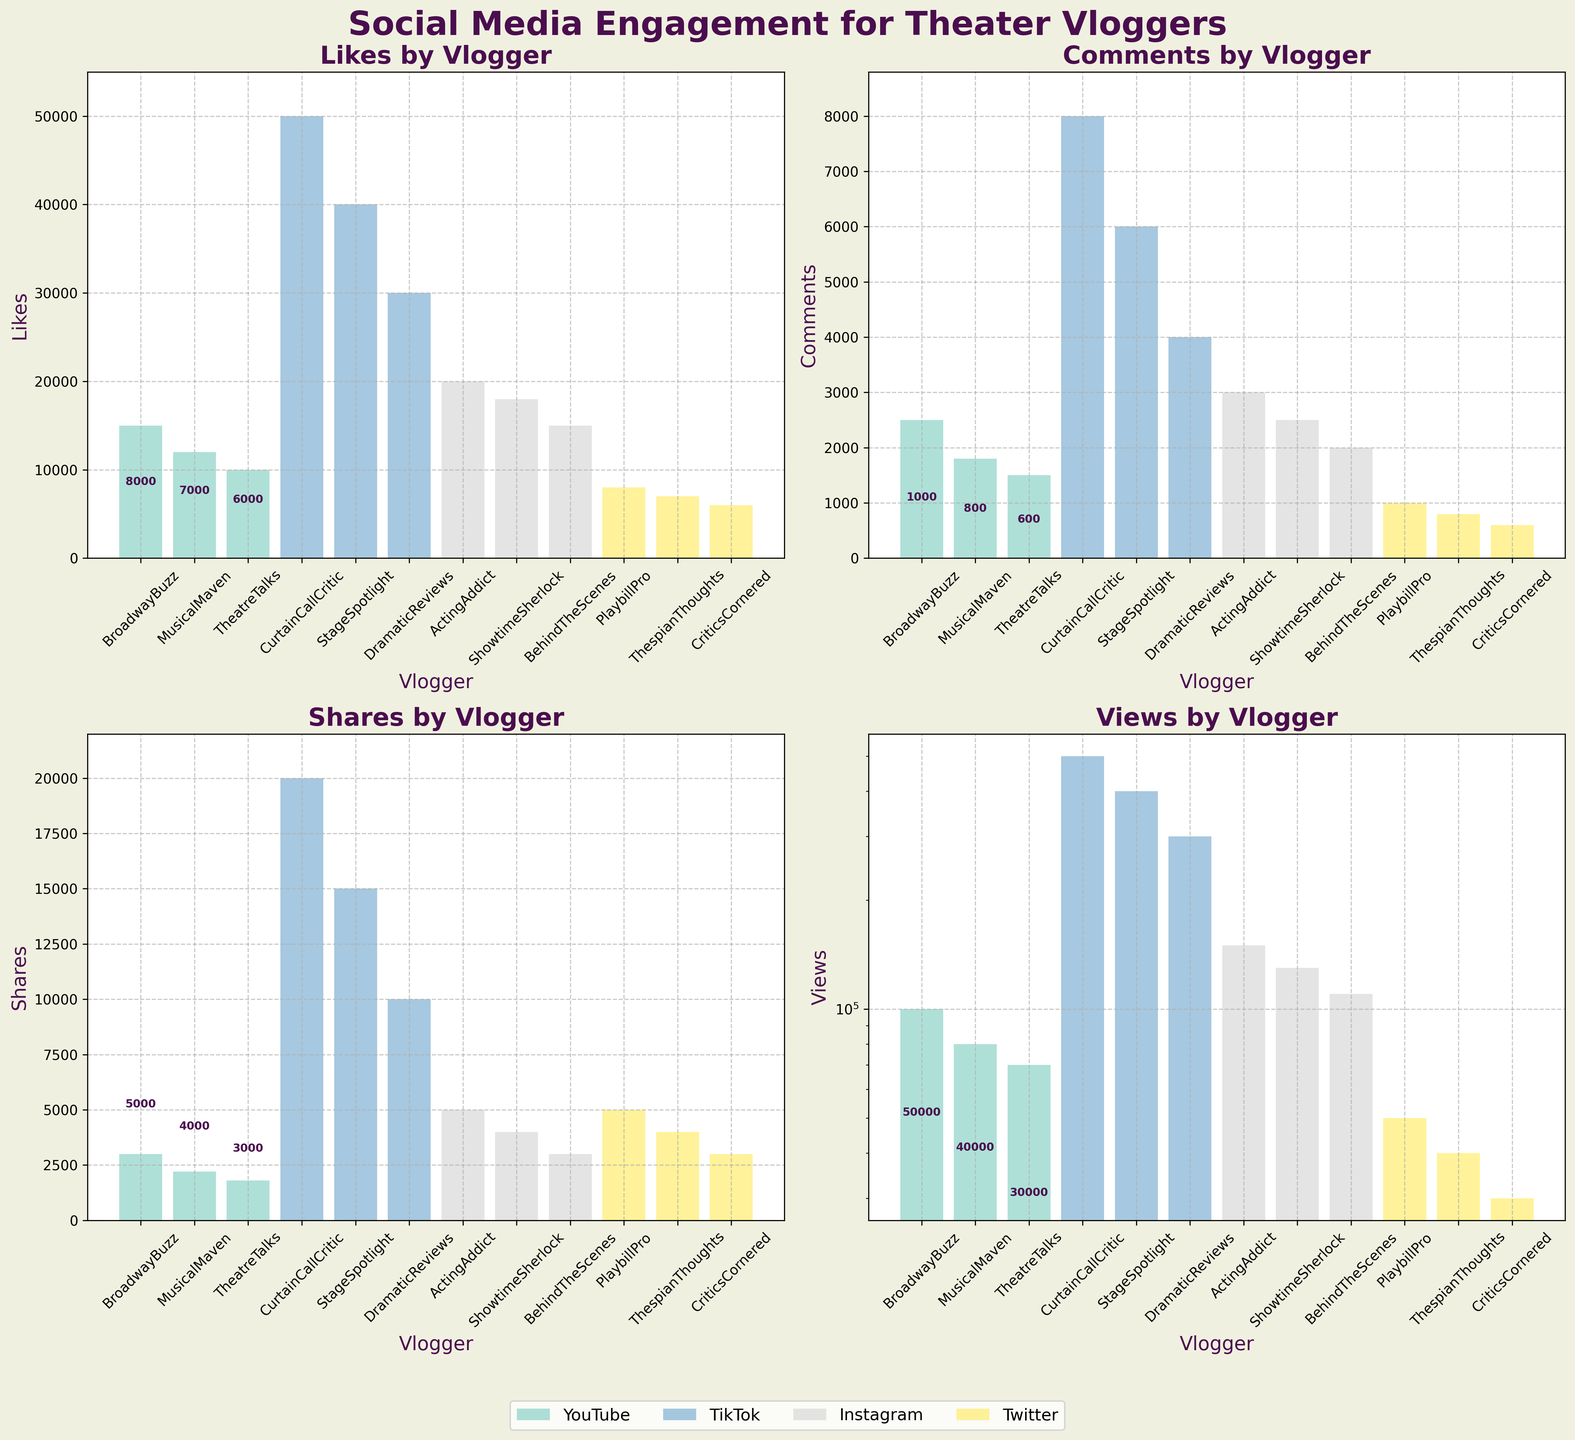What's the title of the figure? The title is at the top of the figure and reads "Social Media Engagement for Theater Vloggers".
Answer: Social Media Engagement for Theater Vloggers Which platform had the vlogger with the most Likes? The subplot for Likes shows that the highest bar is for CurtainCallCritic, which is associated with TikTok.
Answer: TikTok How many TikTok vloggers are included in the charts? From the legend and annotations on the bars in the subplots, there are three TikTok vloggers: CurtainCallCritic, StageSpotlight, and DramaticReviews.
Answer: 3 Which vlogger on YouTube received the most Shares? In the Shares subplot, look for the highest bar among YouTube vloggers—BroadwayBuzz has the highest bar with 3000 shares.
Answer: BroadwayBuzz What is the total number of Views across all platforms for the vlogger 'ActingAddict'? ActingAddict has bars in the Views subplot indicating 150,000 views.
Answer: 150,000 Which platform generally shows higher engagement in terms of Likes? By comparing the heights of the bars in the Likes subplot, TikTok generally has taller bars compared to other platforms, indicating higher engagement.
Answer: TikTok What differences can you observe between the number of Comments received by YouTube vloggers and Instagram vloggers? From the Comments subplot, YouTube vloggers have comments in the range of 1500-2500, while Instagram vloggers have comments ranging from 2000-3000, typically higher on Instagram.
Answer: Instagram generally has more comments Compare the number of Shares between StageSpotlight (TikTok) and ShowTimeSherlock (Instagram). StageSpotlight has 15000 shares while ShowTimeSherlock has 4000 shares, as shown in the Shares subplot.
Answer: StageSpotlight has 11000 more shares than ShowTimeSherlock Which metric shows a logarithmic scale for its y-axis? From the y-axis scales observable in each subplot, the Views subplot shows a logarithmic scale for its y-axis.
Answer: Views Which platform's vloggers show a clear leading performance in terms of overall engagement metrics (Likes, Comments, Shares, Views)? TikTok vloggers consistently have the highest bars across all engagement metrics, indicating they lead in overall performance.
Answer: TikTok 